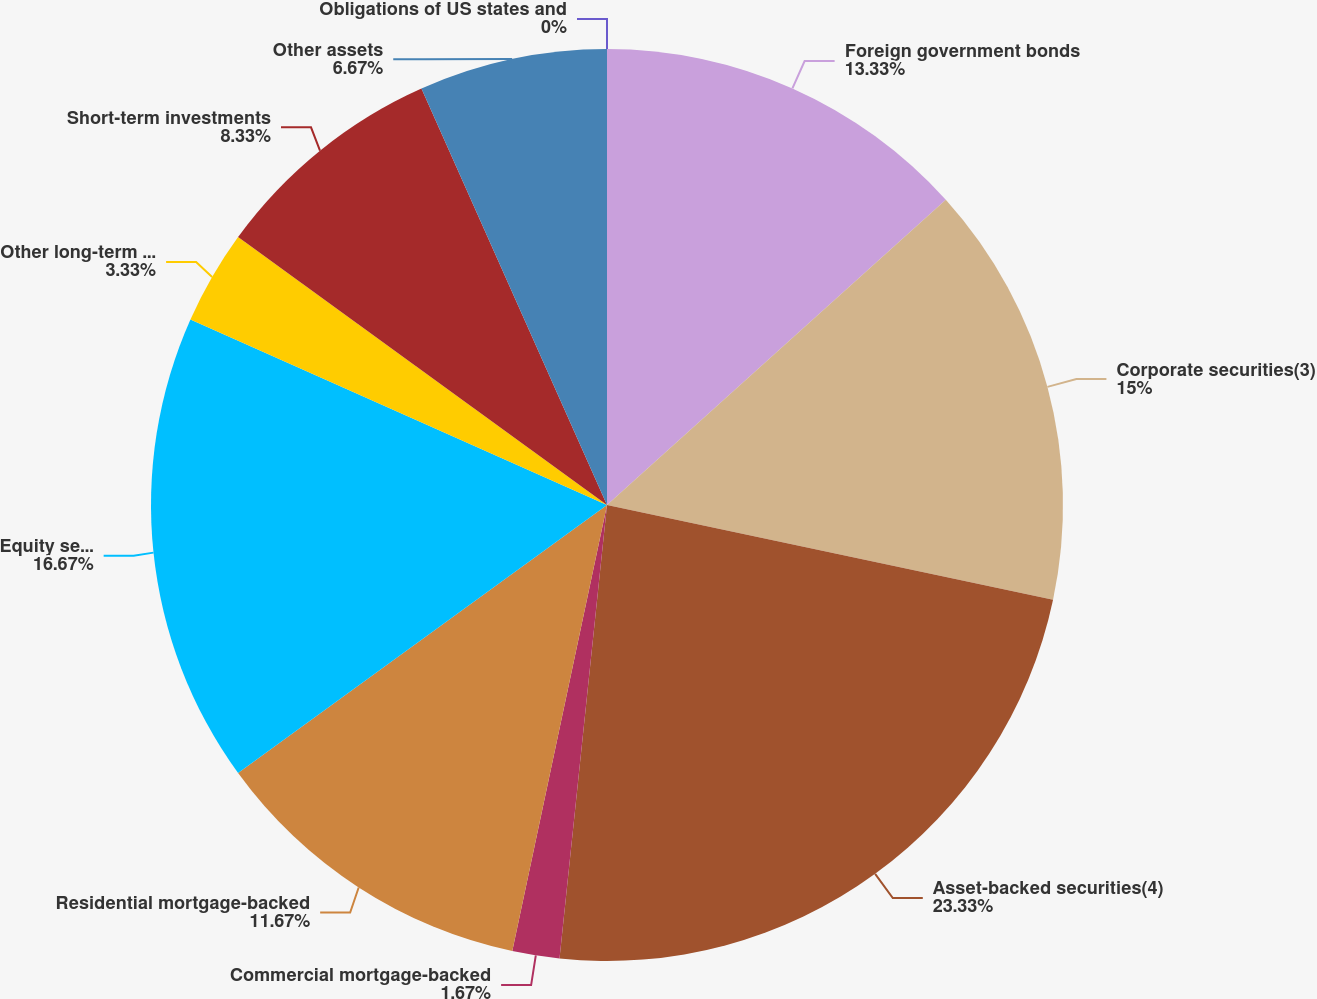<chart> <loc_0><loc_0><loc_500><loc_500><pie_chart><fcel>Obligations of US states and<fcel>Foreign government bonds<fcel>Corporate securities(3)<fcel>Asset-backed securities(4)<fcel>Commercial mortgage-backed<fcel>Residential mortgage-backed<fcel>Equity securities<fcel>Other long-term investments<fcel>Short-term investments<fcel>Other assets<nl><fcel>0.0%<fcel>13.33%<fcel>15.0%<fcel>23.33%<fcel>1.67%<fcel>11.67%<fcel>16.67%<fcel>3.33%<fcel>8.33%<fcel>6.67%<nl></chart> 